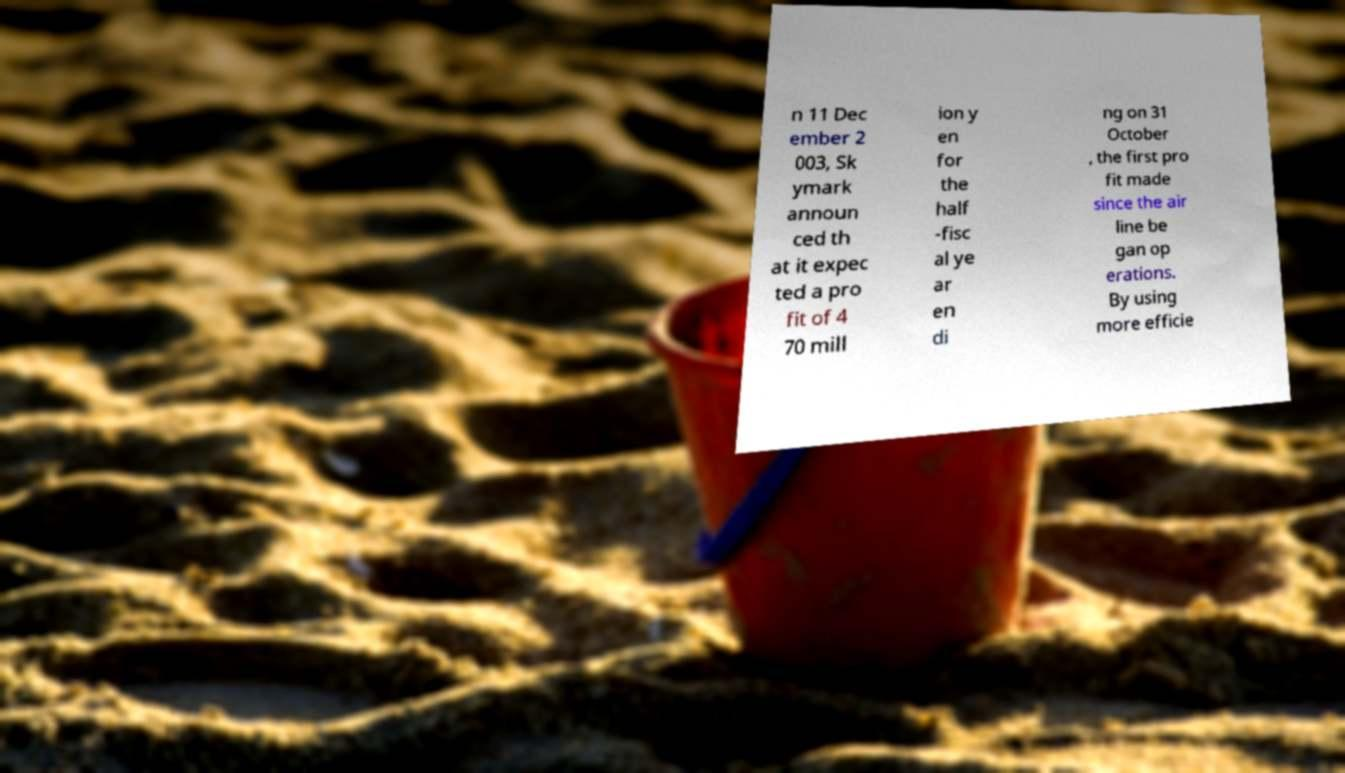Could you extract and type out the text from this image? n 11 Dec ember 2 003, Sk ymark announ ced th at it expec ted a pro fit of 4 70 mill ion y en for the half -fisc al ye ar en di ng on 31 October , the first pro fit made since the air line be gan op erations. By using more efficie 